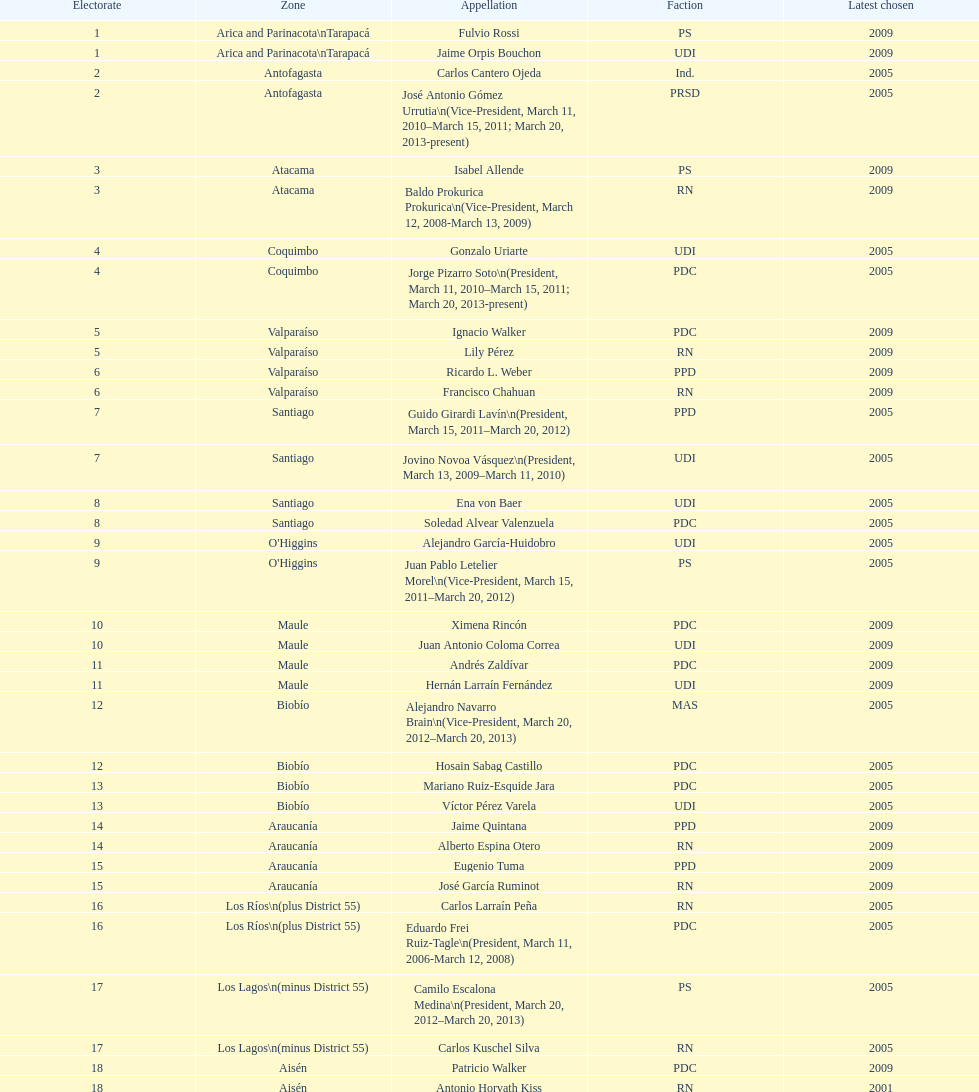When was antonio horvath kiss last elected? 2001. 